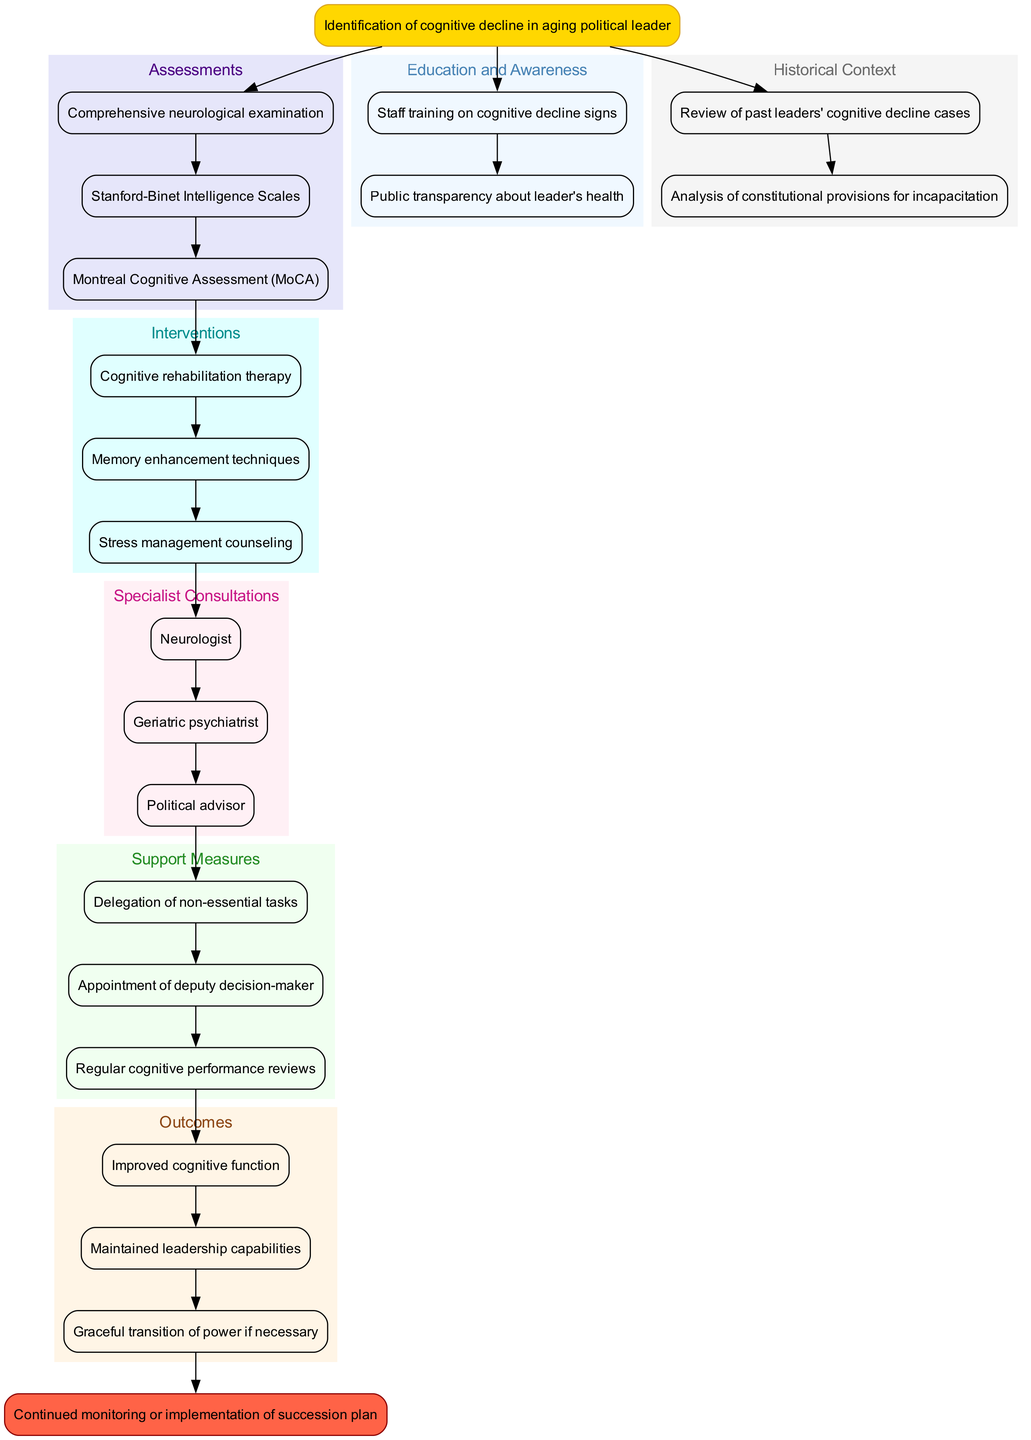What is the starting point of the clinical pathway? The pathway begins with the "Identification of cognitive decline in aging political leader." This is explicitly labeled as the starting point in the diagram.
Answer: Identification of cognitive decline in aging political leader How many assessments are listed in the diagram? The diagram enumerates three assessments related to cognitive decline, as shown in the assessments cluster.
Answer: 3 Which intervention focuses on improving memory? "Memory enhancement techniques" is specifically included as an intervention aimed at improving memory in the interventions section of the diagram.
Answer: Memory enhancement techniques What is the end point of the clinical pathway? The diagram clearly states that the end point of the pathway is "Continued monitoring or implementation of succession plan," highlighted in the end node.
Answer: Continued monitoring or implementation of succession plan Which type of specialist consultation is included besides the neurologist? "Geriatric psychiatrist" is listed as the second specialist consultation, alongside the neurologist, in the specialist consultations section.
Answer: Geriatric psychiatrist What are the outcomes aimed for in this pathway? The outcomes include "Improved cognitive function," "Maintained leadership capabilities," and "Graceful transition of power if necessary," indicating the desired results from the interventions and support measures.
Answer: Improved cognitive function, Maintained leadership capabilities, Graceful transition of power if necessary How does the pathway incorporate historical context? The historical context is included as a separate section where it describes reviewing past leaders' cognitive decline cases and analyzing constitutional provisions for incapacitation, indicating its importance in assessing current cases.
Answer: Review of past leaders' cognitive decline cases, Analysis of constitutional provisions for incapacitation What support measure involves leadership delegation? The support measure "Delegation of non-essential tasks" specifically involves the process of leader delegating tasks to manage cognitive decline effectively within the political environment.
Answer: Delegation of non-essential tasks What type of awareness is emphasized for staff in the education section? The diagram emphasizes "Staff training on cognitive decline signs" to educate staff on recognizing signs of cognitive decline, which is critical for addressing issues promptly.
Answer: Staff training on cognitive decline signs 